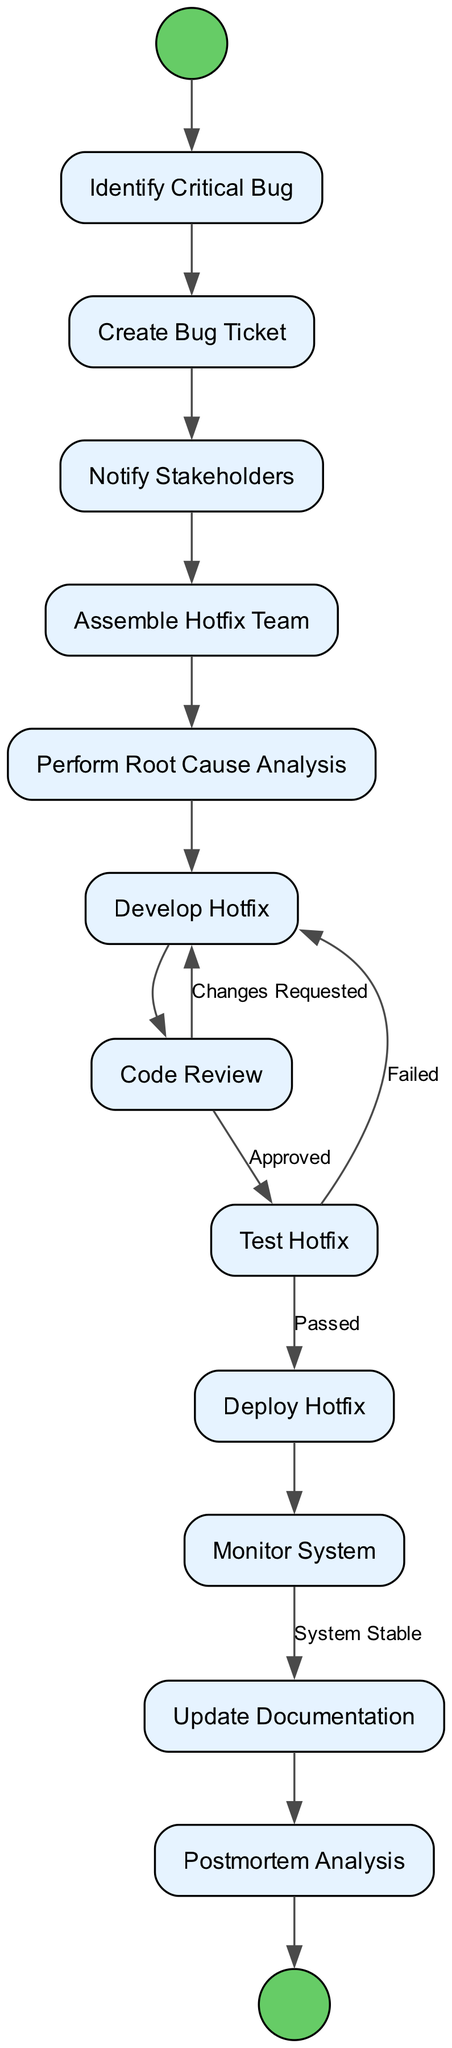What is the first activity in the diagram? The first activity node is labeled as "Identify Critical Bug", which is the starting point and the initial action taken in the process.
Answer: Identify Critical Bug How many activities are there in total? The diagram lists 12 distinct activities related to handling a critical bug, which can be counted in the activities section provided.
Answer: 12 What is the last activity before the postmortem analysis? "Update Documentation" is the activity immediately preceding "Postmortem Analysis" based on the transition flow shown in the diagram.
Answer: Update Documentation Which activity requires stakeholder notification before any other steps? "Notify Stakeholders" must be completed after "Create Bug Ticket" but before forming the hotfix team, indicating it's a key step in the sequence.
Answer: Notify Stakeholders What condition must be met for the hotfix to proceed to deployment? The condition for moving forward from "Test Hotfix" to "Deploy Hotfix" is that the tests must be "Passed", indicating that the hotfix has successfully cleared testing.
Answer: Passed What happens if the code review requests changes? If changes are requested during the "Code Review", the process loops back to "Develop Hotfix", meaning that revisions must be made before proceeding.
Answer: Develop Hotfix How many transitions are there in this diagram? By examining the provided transitions, there are 13 defined connections from one activity to another within the process.
Answer: 13 What step comes after monitoring the system? Following "Monitor System", the next activity is "Update Documentation", which ensures that all changes and fixes are recorded after the hotfix is evaluated in the live environment.
Answer: Update Documentation Which activity is performed after the hotfix is developed? The next step after "Develop Hotfix" is "Code Review", which is crucial for verifying that the hotfix is appropriate and does not introduce new issues.
Answer: Code Review What type of team is assembled to handle the critical bug? A "Hotfix Team" consisting of senior developers and testers is gathered specifically to address the urgent bug, indicating the team is specialized for this task.
Answer: Hotfix Team 